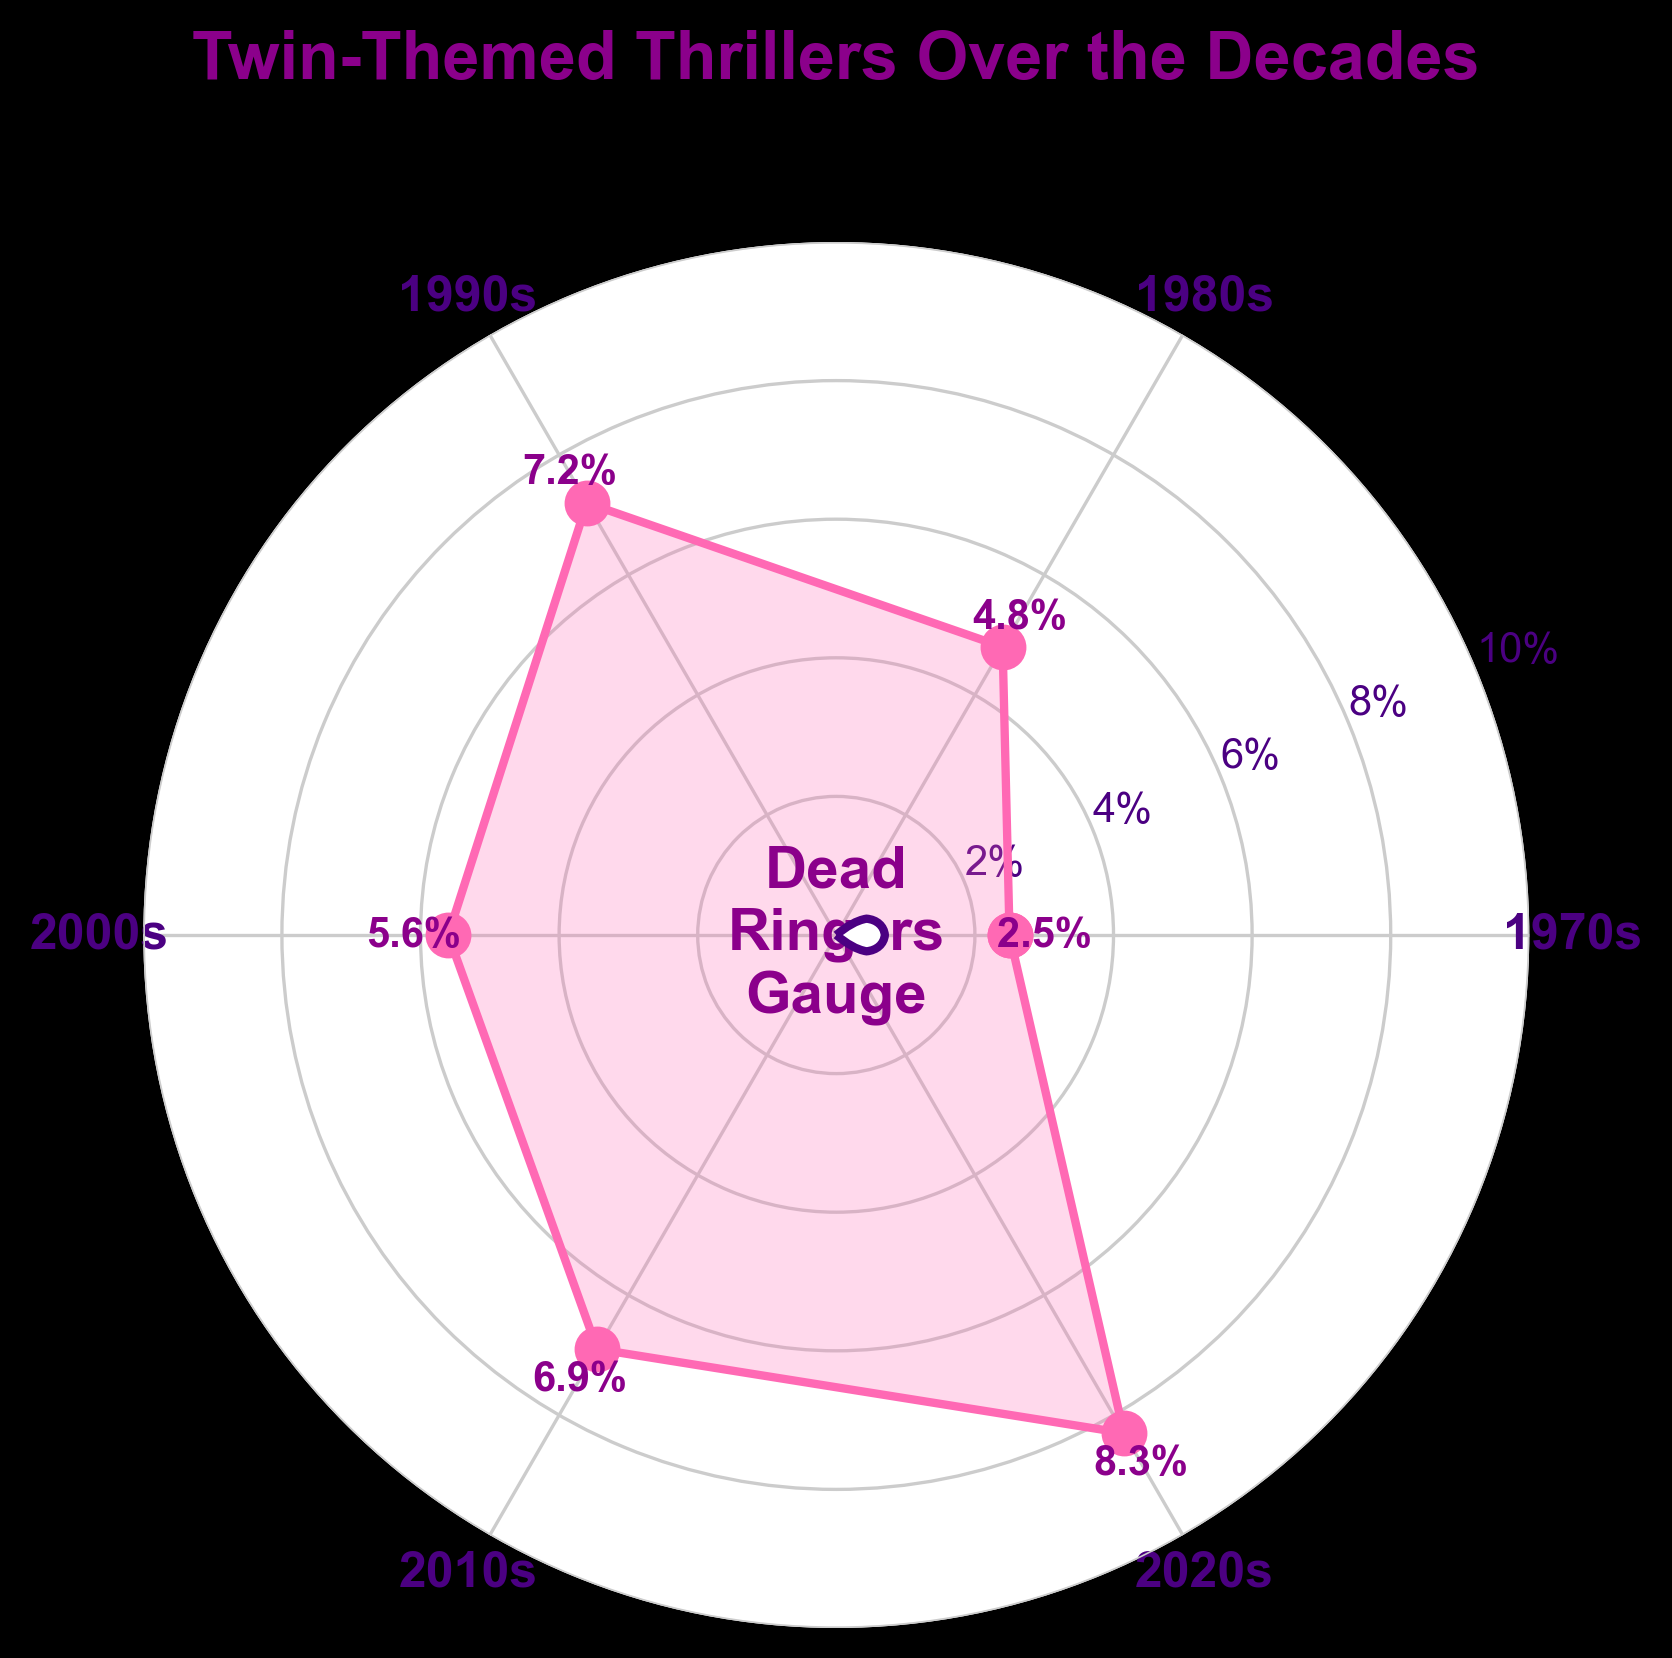Which decade has the highest percentage of twin-themed thriller movies? To find the highest percentage, look at the values marked on the plot and identify the decade with the highest value. The highest value is 8.3% in the 2020s.
Answer: 2020s What is the title of the figure? The title is typically located at the top of a plot. Here, it reads "Twin-Themed Thrillers Over the Decades".
Answer: Twin-Themed Thrillers Over the Decades How many decades are represented on the plot? Count the number of unique labeled angles (data points) on the plot. The decades shown are the 1970s, 1980s, 1990s, 2000s, 2010s, and 2020s, totaling six decades.
Answer: 6 Which decade has the lowest percentage of twin-themed thriller movies? To find the lowest percentage, look at the values marked on the plot and identify the decade with the lowest value. The lowest value is 2.5% in the 1970s.
Answer: 1970s What is the range of percentages displayed on the y-axis? Look at the y-axis and identify the minimum and maximum points. Here, the range of percentages is from 0% to 10%.
Answer: 0% to 10% Which two consecutive decades show a decrease in percentage of twin-themed thrillers? Examine the plot for any consecutive sequence where the percentage decreases from one decade to the next. The decrease occurs from the 1990s (7.2%) to the 2000s (5.6%).
Answer: 1990s to 2000s What is the overall trend in the percentage of twin-themed thriller movies over these decades? To find the general direction of the percentages, analyze the values over time. The trend shows fluctuations but generally increases from 2.5% in the 1970s to 8.3% in the 2020s.
Answer: Increasing How much did the percentage change from the 1990s to the 2010s? Calculate the difference between the percentage in the 2010s (6.9%) and the 1990s (7.2%). The change is 6.9% - 7.2% = -0.3%.
Answer: -0.3% What is the average percentage of twin-themed thrillers over the decades shown? Calculate the average by summing all the percentages and dividing by the number of decades. (2.5 + 4.8 + 7.2 + 5.6 + 6.9 + 8.3) / 6 = 5.88333 (approximately 5.9).
Answer: 5.9% 